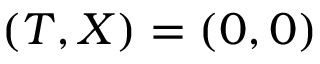<formula> <loc_0><loc_0><loc_500><loc_500>( T , X ) = ( 0 , 0 )</formula> 